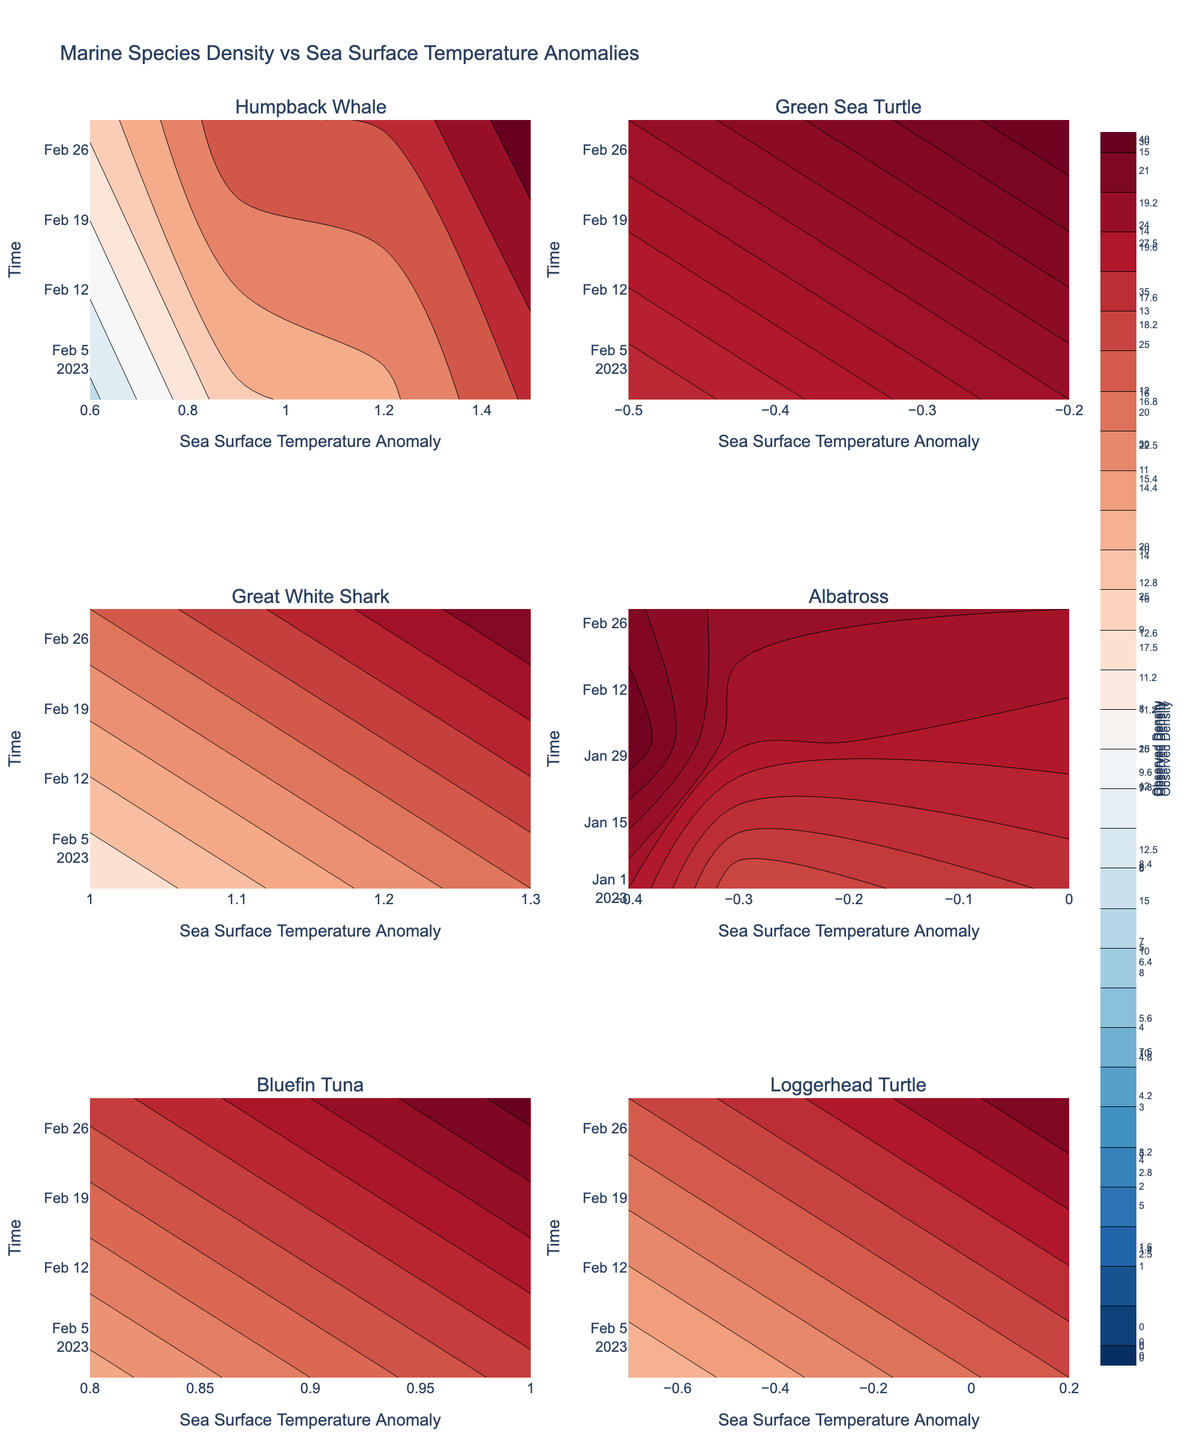What is the title of the plot? The title is typically displayed at the top of the plot and summarizes the overall subject of the visualization.
Answer: Marine Species Density vs Sea Surface Temperature Anomalies Which species has the highest observed density in March 2023? By examining the density values in March 2023 on the charts, you can see which species has the highest density.
Answer: Great White Shark What is the range of sea surface temperature anomalies for Humpback Whales? Check the x-axis of the subplot for Humpback Whales to determine the range of values.
Answer: 0.6 to 1.5 Which species shows a decrease in observed density as sea surface temperature anomaly increases? Looking at the contour plots, compare the species’ density trends relative to increases in sea surface temperature anomalies. Loggerhead Turtles show a decrease.
Answer: Loggerhead Turtle During which time period do Green Sea Turtles have the highest observed density? By checking the contours for Green Sea Turtles across time, identify the period with the highest density.
Answer: March 2023 How does the observed density of Albatross in February 2023 compare to January 2023? Check the density values for each month and compare them directly. Albatross has a higher density in February 2023 compared to January 2023.
Answer: Higher Is there any species showing no significant change in density over time? Identify species whose contour lines are nearly uniform across the time axis. The Albatross density shows minimal variation over time.
Answer: Albatross Which species appear to have the most significant positive correlation between sea surface temperature anomaly and observed density? Look for species where an increase in temperature anomaly corresponds with an increase in observed density. Great White Shark shows this trend.
Answer: Great White Shark Compare the sea surface temperature anomaly range for Bluefin Tuna and Loggerhead Turtle. Which is wider? Observe the x-axis ranges for both species' subplots and compare their ranges. Bluefin Tuna has a wider anomaly range.
Answer: Bluefin Tuna What is the approximate observed density of Humpback Whales in the North Pacific when the sea surface temperature anomaly is 1.5 in March 2023? Locate the intersection of 1.5 anomaly and March 2023 in the Humpback Whale subplot and read the density. It's approximately 22.
Answer: 22 